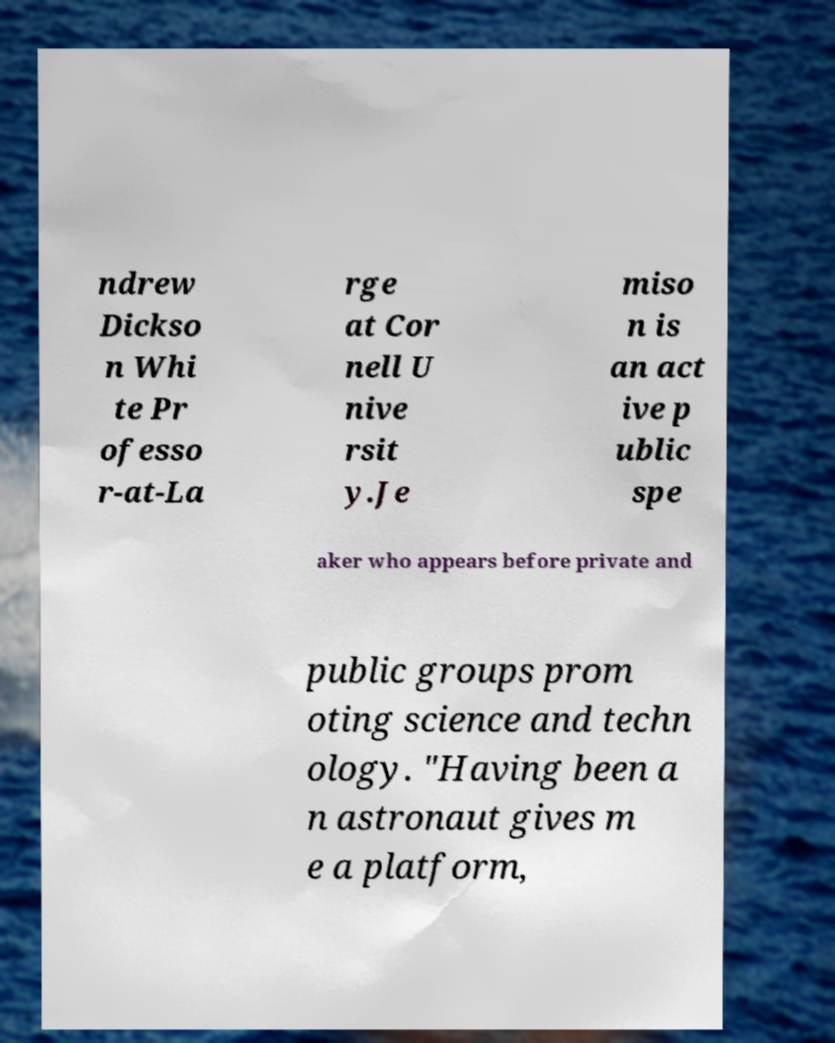I need the written content from this picture converted into text. Can you do that? ndrew Dickso n Whi te Pr ofesso r-at-La rge at Cor nell U nive rsit y.Je miso n is an act ive p ublic spe aker who appears before private and public groups prom oting science and techn ology. "Having been a n astronaut gives m e a platform, 